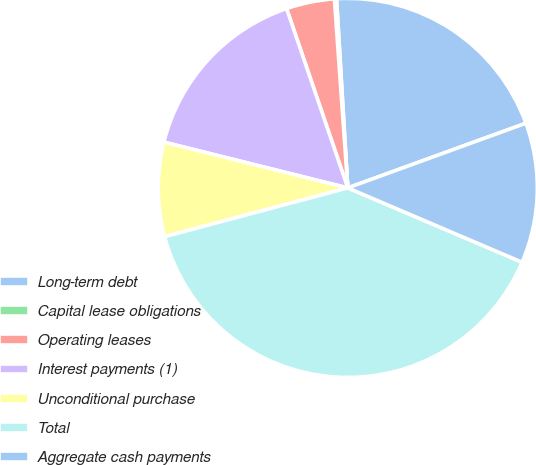Convert chart to OTSL. <chart><loc_0><loc_0><loc_500><loc_500><pie_chart><fcel>Long-term debt<fcel>Capital lease obligations<fcel>Operating leases<fcel>Interest payments (1)<fcel>Unconditional purchase<fcel>Total<fcel>Aggregate cash payments<nl><fcel>20.4%<fcel>0.18%<fcel>4.11%<fcel>15.88%<fcel>8.03%<fcel>39.44%<fcel>11.96%<nl></chart> 